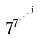<formula> <loc_0><loc_0><loc_500><loc_500>7 ^ { 7 ^ { \cdot ^ { \cdot ^ { \cdot ^ { j } } } } }</formula> 